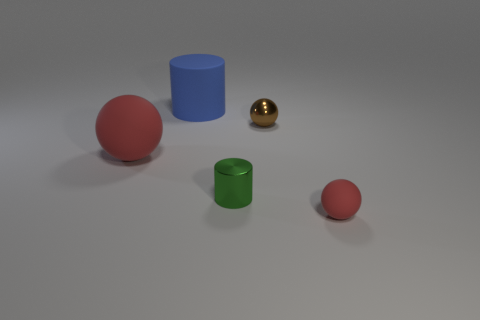Add 2 large red metallic cylinders. How many objects exist? 7 Subtract all brown blocks. How many red spheres are left? 2 Subtract all tiny spheres. How many spheres are left? 1 Subtract all spheres. How many objects are left? 2 Subtract 2 balls. How many balls are left? 1 Subtract 0 yellow cylinders. How many objects are left? 5 Subtract all red balls. Subtract all cyan cylinders. How many balls are left? 1 Subtract all large blue matte cylinders. Subtract all big rubber cylinders. How many objects are left? 3 Add 3 matte spheres. How many matte spheres are left? 5 Add 1 tiny cyan cylinders. How many tiny cyan cylinders exist? 1 